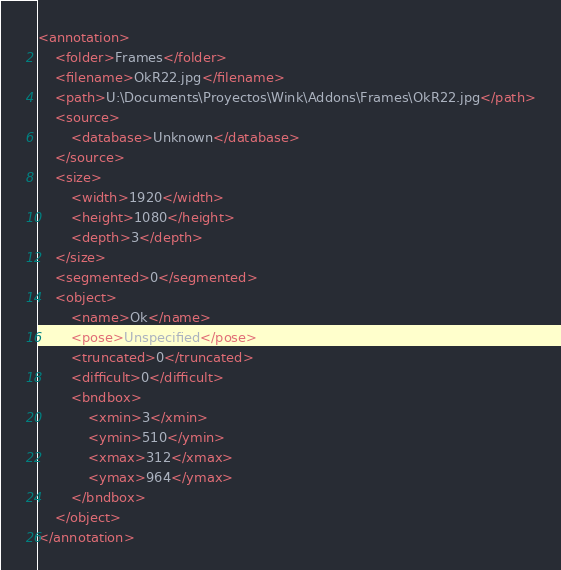Convert code to text. <code><loc_0><loc_0><loc_500><loc_500><_XML_><annotation>
	<folder>Frames</folder>
	<filename>OkR22.jpg</filename>
	<path>U:\Documents\Proyectos\Wink\Addons\Frames\OkR22.jpg</path>
	<source>
		<database>Unknown</database>
	</source>
	<size>
		<width>1920</width>
		<height>1080</height>
		<depth>3</depth>
	</size>
	<segmented>0</segmented>
	<object>
		<name>Ok</name>
		<pose>Unspecified</pose>
		<truncated>0</truncated>
		<difficult>0</difficult>
		<bndbox>
			<xmin>3</xmin>
			<ymin>510</ymin>
			<xmax>312</xmax>
			<ymax>964</ymax>
		</bndbox>
	</object>
</annotation>
</code> 